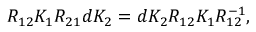<formula> <loc_0><loc_0><loc_500><loc_500>R _ { 1 2 } K _ { 1 } R _ { 2 1 } d K _ { 2 } = d K _ { 2 } R _ { 1 2 } K _ { 1 } R _ { 1 2 } ^ { - 1 } ,</formula> 